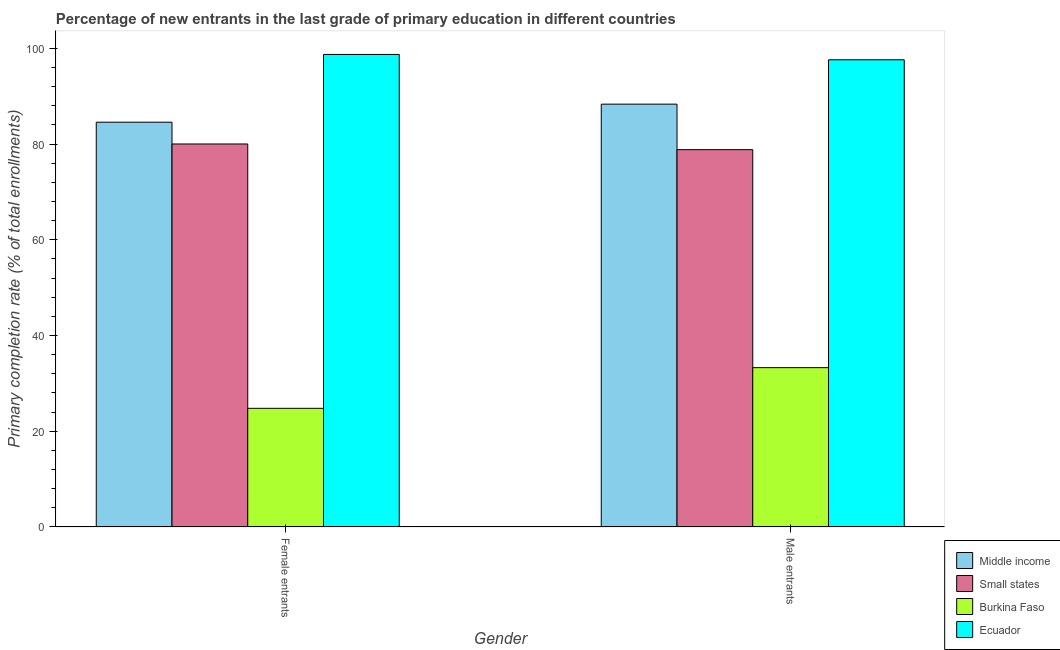How many different coloured bars are there?
Your answer should be compact. 4. How many groups of bars are there?
Provide a short and direct response. 2. Are the number of bars on each tick of the X-axis equal?
Keep it short and to the point. Yes. How many bars are there on the 2nd tick from the right?
Ensure brevity in your answer.  4. What is the label of the 2nd group of bars from the left?
Your response must be concise. Male entrants. What is the primary completion rate of male entrants in Burkina Faso?
Provide a short and direct response. 33.29. Across all countries, what is the maximum primary completion rate of female entrants?
Give a very brief answer. 98.73. Across all countries, what is the minimum primary completion rate of male entrants?
Provide a short and direct response. 33.29. In which country was the primary completion rate of female entrants maximum?
Give a very brief answer. Ecuador. In which country was the primary completion rate of female entrants minimum?
Make the answer very short. Burkina Faso. What is the total primary completion rate of male entrants in the graph?
Keep it short and to the point. 298.08. What is the difference between the primary completion rate of male entrants in Middle income and that in Small states?
Provide a short and direct response. 9.51. What is the difference between the primary completion rate of female entrants in Middle income and the primary completion rate of male entrants in Small states?
Offer a very short reply. 5.74. What is the average primary completion rate of male entrants per country?
Ensure brevity in your answer.  74.52. What is the difference between the primary completion rate of male entrants and primary completion rate of female entrants in Small states?
Your answer should be very brief. -1.19. In how many countries, is the primary completion rate of male entrants greater than 12 %?
Provide a succinct answer. 4. What is the ratio of the primary completion rate of male entrants in Small states to that in Burkina Faso?
Keep it short and to the point. 2.37. Is the primary completion rate of male entrants in Small states less than that in Middle income?
Provide a short and direct response. Yes. In how many countries, is the primary completion rate of male entrants greater than the average primary completion rate of male entrants taken over all countries?
Offer a terse response. 3. What does the 1st bar from the left in Female entrants represents?
Ensure brevity in your answer.  Middle income. What does the 2nd bar from the right in Female entrants represents?
Offer a very short reply. Burkina Faso. How many bars are there?
Offer a very short reply. 8. Are all the bars in the graph horizontal?
Your answer should be compact. No. How many countries are there in the graph?
Provide a short and direct response. 4. What is the difference between two consecutive major ticks on the Y-axis?
Your response must be concise. 20. What is the title of the graph?
Your answer should be compact. Percentage of new entrants in the last grade of primary education in different countries. What is the label or title of the Y-axis?
Make the answer very short. Primary completion rate (% of total enrollments). What is the Primary completion rate (% of total enrollments) of Middle income in Female entrants?
Provide a succinct answer. 84.57. What is the Primary completion rate (% of total enrollments) of Small states in Female entrants?
Keep it short and to the point. 80.02. What is the Primary completion rate (% of total enrollments) of Burkina Faso in Female entrants?
Offer a very short reply. 24.79. What is the Primary completion rate (% of total enrollments) in Ecuador in Female entrants?
Offer a very short reply. 98.73. What is the Primary completion rate (% of total enrollments) in Middle income in Male entrants?
Give a very brief answer. 88.34. What is the Primary completion rate (% of total enrollments) in Small states in Male entrants?
Ensure brevity in your answer.  78.84. What is the Primary completion rate (% of total enrollments) in Burkina Faso in Male entrants?
Offer a terse response. 33.29. What is the Primary completion rate (% of total enrollments) of Ecuador in Male entrants?
Keep it short and to the point. 97.61. Across all Gender, what is the maximum Primary completion rate (% of total enrollments) in Middle income?
Provide a succinct answer. 88.34. Across all Gender, what is the maximum Primary completion rate (% of total enrollments) of Small states?
Give a very brief answer. 80.02. Across all Gender, what is the maximum Primary completion rate (% of total enrollments) of Burkina Faso?
Your answer should be compact. 33.29. Across all Gender, what is the maximum Primary completion rate (% of total enrollments) of Ecuador?
Offer a very short reply. 98.73. Across all Gender, what is the minimum Primary completion rate (% of total enrollments) in Middle income?
Provide a short and direct response. 84.57. Across all Gender, what is the minimum Primary completion rate (% of total enrollments) of Small states?
Make the answer very short. 78.84. Across all Gender, what is the minimum Primary completion rate (% of total enrollments) in Burkina Faso?
Give a very brief answer. 24.79. Across all Gender, what is the minimum Primary completion rate (% of total enrollments) of Ecuador?
Offer a very short reply. 97.61. What is the total Primary completion rate (% of total enrollments) of Middle income in the graph?
Offer a terse response. 172.91. What is the total Primary completion rate (% of total enrollments) of Small states in the graph?
Your answer should be compact. 158.86. What is the total Primary completion rate (% of total enrollments) of Burkina Faso in the graph?
Give a very brief answer. 58.08. What is the total Primary completion rate (% of total enrollments) in Ecuador in the graph?
Provide a succinct answer. 196.34. What is the difference between the Primary completion rate (% of total enrollments) of Middle income in Female entrants and that in Male entrants?
Keep it short and to the point. -3.77. What is the difference between the Primary completion rate (% of total enrollments) in Small states in Female entrants and that in Male entrants?
Offer a very short reply. 1.19. What is the difference between the Primary completion rate (% of total enrollments) of Burkina Faso in Female entrants and that in Male entrants?
Keep it short and to the point. -8.5. What is the difference between the Primary completion rate (% of total enrollments) in Ecuador in Female entrants and that in Male entrants?
Make the answer very short. 1.12. What is the difference between the Primary completion rate (% of total enrollments) in Middle income in Female entrants and the Primary completion rate (% of total enrollments) in Small states in Male entrants?
Make the answer very short. 5.74. What is the difference between the Primary completion rate (% of total enrollments) in Middle income in Female entrants and the Primary completion rate (% of total enrollments) in Burkina Faso in Male entrants?
Keep it short and to the point. 51.28. What is the difference between the Primary completion rate (% of total enrollments) of Middle income in Female entrants and the Primary completion rate (% of total enrollments) of Ecuador in Male entrants?
Your answer should be compact. -13.04. What is the difference between the Primary completion rate (% of total enrollments) of Small states in Female entrants and the Primary completion rate (% of total enrollments) of Burkina Faso in Male entrants?
Your answer should be compact. 46.73. What is the difference between the Primary completion rate (% of total enrollments) in Small states in Female entrants and the Primary completion rate (% of total enrollments) in Ecuador in Male entrants?
Offer a very short reply. -17.59. What is the difference between the Primary completion rate (% of total enrollments) in Burkina Faso in Female entrants and the Primary completion rate (% of total enrollments) in Ecuador in Male entrants?
Offer a terse response. -72.82. What is the average Primary completion rate (% of total enrollments) of Middle income per Gender?
Your answer should be very brief. 86.46. What is the average Primary completion rate (% of total enrollments) of Small states per Gender?
Provide a short and direct response. 79.43. What is the average Primary completion rate (% of total enrollments) of Burkina Faso per Gender?
Ensure brevity in your answer.  29.04. What is the average Primary completion rate (% of total enrollments) of Ecuador per Gender?
Make the answer very short. 98.17. What is the difference between the Primary completion rate (% of total enrollments) in Middle income and Primary completion rate (% of total enrollments) in Small states in Female entrants?
Offer a terse response. 4.55. What is the difference between the Primary completion rate (% of total enrollments) of Middle income and Primary completion rate (% of total enrollments) of Burkina Faso in Female entrants?
Offer a terse response. 59.78. What is the difference between the Primary completion rate (% of total enrollments) of Middle income and Primary completion rate (% of total enrollments) of Ecuador in Female entrants?
Your response must be concise. -14.15. What is the difference between the Primary completion rate (% of total enrollments) in Small states and Primary completion rate (% of total enrollments) in Burkina Faso in Female entrants?
Offer a terse response. 55.23. What is the difference between the Primary completion rate (% of total enrollments) of Small states and Primary completion rate (% of total enrollments) of Ecuador in Female entrants?
Provide a succinct answer. -18.7. What is the difference between the Primary completion rate (% of total enrollments) of Burkina Faso and Primary completion rate (% of total enrollments) of Ecuador in Female entrants?
Your response must be concise. -73.93. What is the difference between the Primary completion rate (% of total enrollments) of Middle income and Primary completion rate (% of total enrollments) of Small states in Male entrants?
Offer a terse response. 9.51. What is the difference between the Primary completion rate (% of total enrollments) of Middle income and Primary completion rate (% of total enrollments) of Burkina Faso in Male entrants?
Ensure brevity in your answer.  55.05. What is the difference between the Primary completion rate (% of total enrollments) in Middle income and Primary completion rate (% of total enrollments) in Ecuador in Male entrants?
Keep it short and to the point. -9.27. What is the difference between the Primary completion rate (% of total enrollments) in Small states and Primary completion rate (% of total enrollments) in Burkina Faso in Male entrants?
Provide a succinct answer. 45.54. What is the difference between the Primary completion rate (% of total enrollments) in Small states and Primary completion rate (% of total enrollments) in Ecuador in Male entrants?
Provide a short and direct response. -18.77. What is the difference between the Primary completion rate (% of total enrollments) of Burkina Faso and Primary completion rate (% of total enrollments) of Ecuador in Male entrants?
Offer a very short reply. -64.32. What is the ratio of the Primary completion rate (% of total enrollments) in Middle income in Female entrants to that in Male entrants?
Your response must be concise. 0.96. What is the ratio of the Primary completion rate (% of total enrollments) of Burkina Faso in Female entrants to that in Male entrants?
Your answer should be compact. 0.74. What is the ratio of the Primary completion rate (% of total enrollments) of Ecuador in Female entrants to that in Male entrants?
Ensure brevity in your answer.  1.01. What is the difference between the highest and the second highest Primary completion rate (% of total enrollments) of Middle income?
Keep it short and to the point. 3.77. What is the difference between the highest and the second highest Primary completion rate (% of total enrollments) in Small states?
Keep it short and to the point. 1.19. What is the difference between the highest and the second highest Primary completion rate (% of total enrollments) of Burkina Faso?
Provide a succinct answer. 8.5. What is the difference between the highest and the second highest Primary completion rate (% of total enrollments) in Ecuador?
Provide a short and direct response. 1.12. What is the difference between the highest and the lowest Primary completion rate (% of total enrollments) in Middle income?
Offer a terse response. 3.77. What is the difference between the highest and the lowest Primary completion rate (% of total enrollments) in Small states?
Make the answer very short. 1.19. What is the difference between the highest and the lowest Primary completion rate (% of total enrollments) in Burkina Faso?
Your response must be concise. 8.5. What is the difference between the highest and the lowest Primary completion rate (% of total enrollments) in Ecuador?
Your answer should be compact. 1.12. 